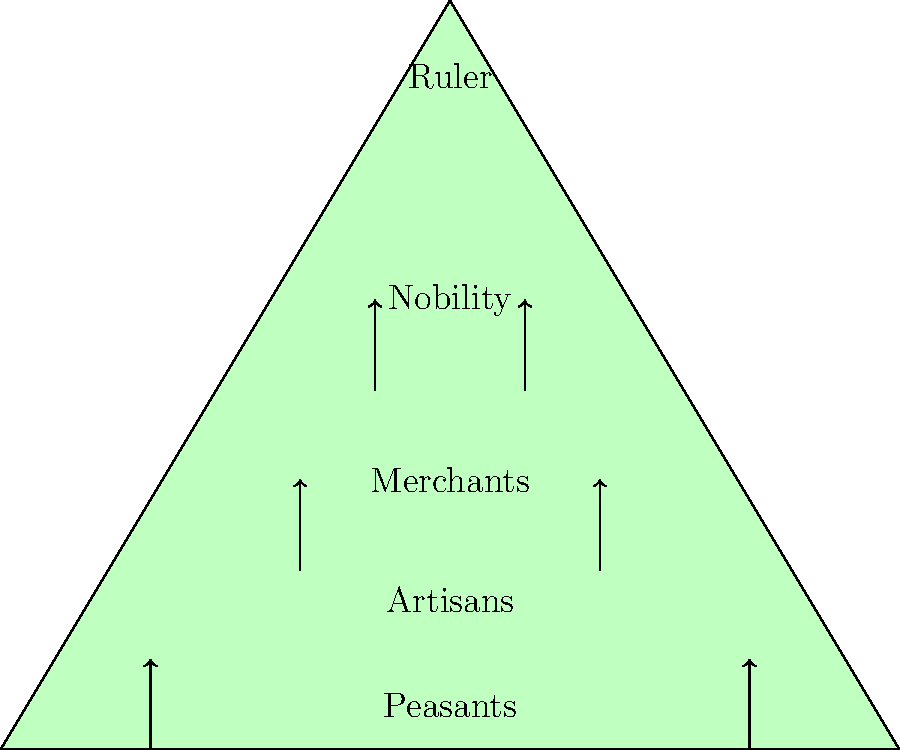Based on the pyramid-shaped infographic representing the Mayan social hierarchy, which group would have had the most direct influence on agricultural production and why? How might this group's position in the social structure have affected Mayan civilization's ability to sustain itself during periods of environmental stress? To answer this question, we need to analyze the Mayan social hierarchy as depicted in the pyramid infographic:

1. The pyramid shows five distinct social classes, from bottom to top:
   - Peasants
   - Artisans
   - Merchants
   - Nobility
   - Ruler

2. The peasants, at the bottom of the pyramid, would have had the most direct influence on agricultural production because:
   a. They formed the largest group in Mayan society.
   b. They were responsible for farming and food production.
   c. Their daily lives revolved around agricultural activities.

3. The peasants' position at the bottom of the social structure affected Mayan civilization's sustainability during environmental stress:
   a. They bore the brunt of agricultural challenges, such as droughts or crop failures.
   b. Their labor was crucial for producing surplus food to support the upper classes.
   c. Any disruption in their ability to produce food would have immediate effects on the entire society.

4. During periods of environmental stress:
   a. Peasants would be the first to experience food shortages.
   b. Their reduced productivity would impact the entire social structure.
   c. The stability of the entire civilization depended on their ability to adapt to changing environmental conditions.

5. The hierarchical structure meant that:
   a. Peasants had limited access to resources that could help mitigate environmental challenges.
   b. Knowledge and decision-making power were concentrated at the top of the pyramid.
   c. There might have been delays in implementing adaptive strategies due to the social distance between peasants and rulers.

6. However, the peasants' position also meant that:
   a. They had intimate knowledge of local environmental conditions.
   b. They could potentially develop innovative agricultural techniques to cope with stress.
   c. Their success or failure in adapting to environmental changes would directly impact the sustainability of Mayan civilization.
Answer: Peasants; their large numbers, direct involvement in agriculture, and position at the base of the social hierarchy made them crucial for food production and societal sustainability during environmental stress. 